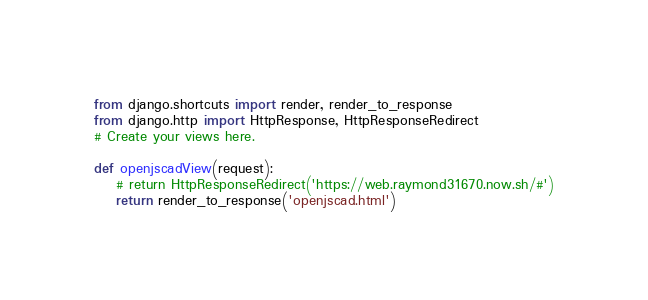<code> <loc_0><loc_0><loc_500><loc_500><_Python_>from django.shortcuts import render, render_to_response
from django.http import HttpResponse, HttpResponseRedirect
# Create your views here.

def openjscadView(request):
    # return HttpResponseRedirect('https://web.raymond31670.now.sh/#')
    return render_to_response('openjscad.html')</code> 